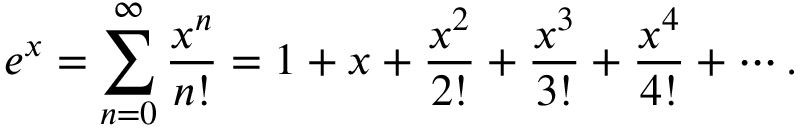Convert formula to latex. <formula><loc_0><loc_0><loc_500><loc_500>e ^ { x } = \sum _ { n = 0 } ^ { \infty } { \frac { x ^ { n } } { n ! } } = 1 + x + { \frac { x ^ { 2 } } { 2 ! } } + { \frac { x ^ { 3 } } { 3 ! } } + { \frac { x ^ { 4 } } { 4 ! } } + \cdots .</formula> 